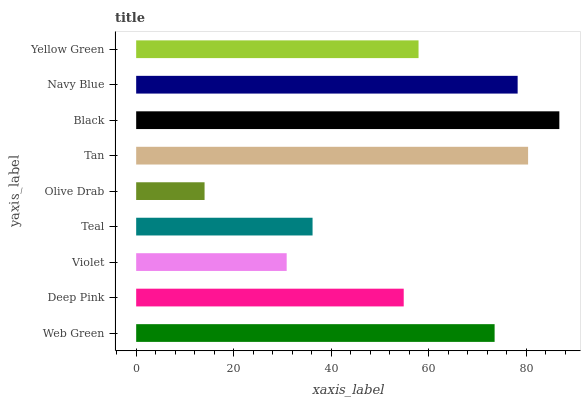Is Olive Drab the minimum?
Answer yes or no. Yes. Is Black the maximum?
Answer yes or no. Yes. Is Deep Pink the minimum?
Answer yes or no. No. Is Deep Pink the maximum?
Answer yes or no. No. Is Web Green greater than Deep Pink?
Answer yes or no. Yes. Is Deep Pink less than Web Green?
Answer yes or no. Yes. Is Deep Pink greater than Web Green?
Answer yes or no. No. Is Web Green less than Deep Pink?
Answer yes or no. No. Is Yellow Green the high median?
Answer yes or no. Yes. Is Yellow Green the low median?
Answer yes or no. Yes. Is Teal the high median?
Answer yes or no. No. Is Navy Blue the low median?
Answer yes or no. No. 